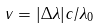Convert formula to latex. <formula><loc_0><loc_0><loc_500><loc_500>v = | \Delta \lambda | c / \lambda _ { 0 }</formula> 